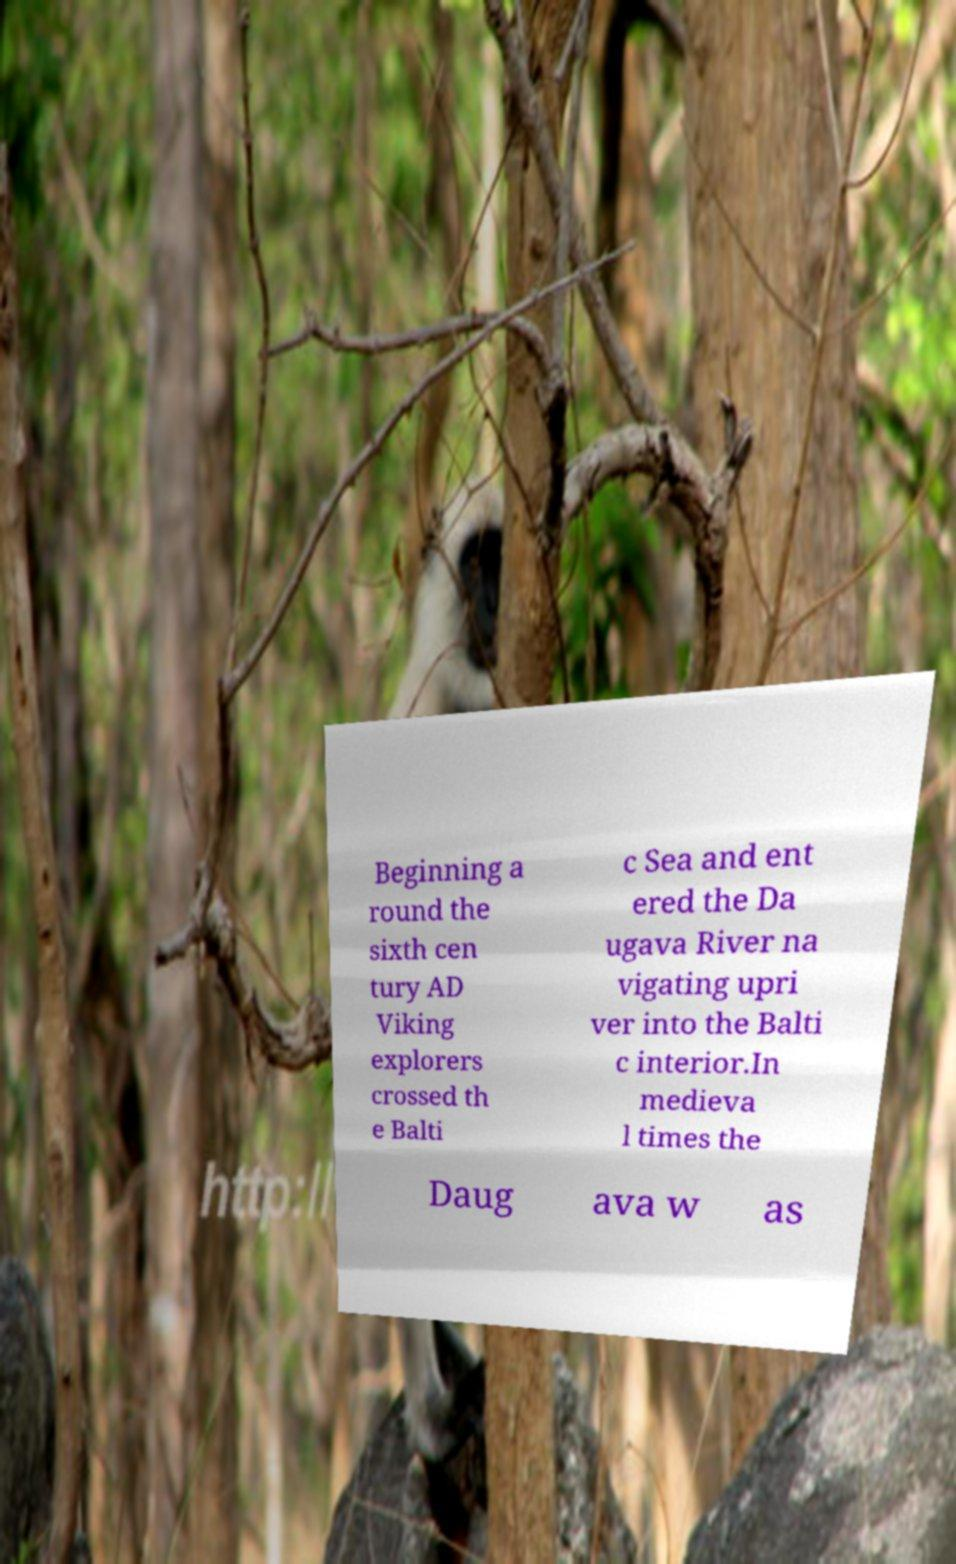There's text embedded in this image that I need extracted. Can you transcribe it verbatim? Beginning a round the sixth cen tury AD Viking explorers crossed th e Balti c Sea and ent ered the Da ugava River na vigating upri ver into the Balti c interior.In medieva l times the Daug ava w as 